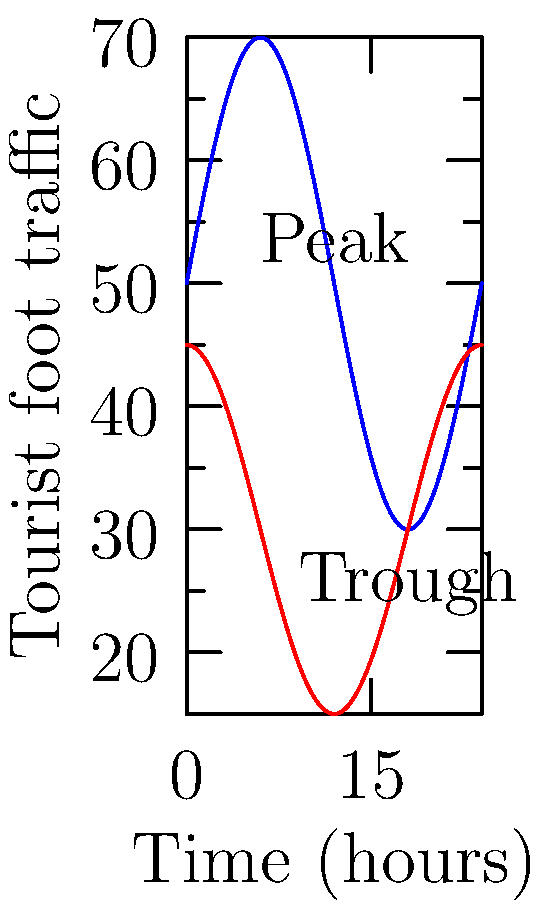The graph shows the tourist foot traffic across the Panmen Gate bridge in Suzhou over a 24-hour period for both weekdays and weekends. The weekday function is given by $f(t) = 50 + 20\sin(\frac{\pi t}{12})$ and the weekend function by $g(t) = 30 + 15\cos(\frac{\pi t}{12})$, where $t$ is the time in hours. At what time is the rate of change of weekday foot traffic the greatest, and what is this maximum rate? To find the maximum rate of change, we need to find the maximum value of the derivative of $f(t)$.

1) First, let's find $f'(t)$:
   $f'(t) = 20 \cdot \frac{\pi}{12} \cos(\frac{\pi t}{12}) = \frac{5\pi}{3} \cos(\frac{\pi t}{12})$

2) The maximum value of cosine is 1, which occurs when its argument is 0, $\pi$, $2\pi$, etc.

3) So, we need to solve:
   $\frac{\pi t}{12} = 0, \pi, 2\pi, ...$

4) This gives us:
   $t = 0, 12, 24, ...$

5) Since we're only considering a 24-hour period, the maximum rate of change occurs at $t = 0$ and $t = 12$.

6) The maximum rate is:
   $f'(0) = f'(12) = \frac{5\pi}{3} \approx 5.24$ tourists per hour

7) From the graph, we can see that 12 hours corresponds to noon, which makes sense as it's likely the busiest time.

Therefore, the rate of change of weekday foot traffic is greatest at 0:00 (midnight) and 12:00 (noon), with a maximum rate of $\frac{5\pi}{3}$ tourists per hour.
Answer: 12:00 (noon), $\frac{5\pi}{3}$ tourists/hour 